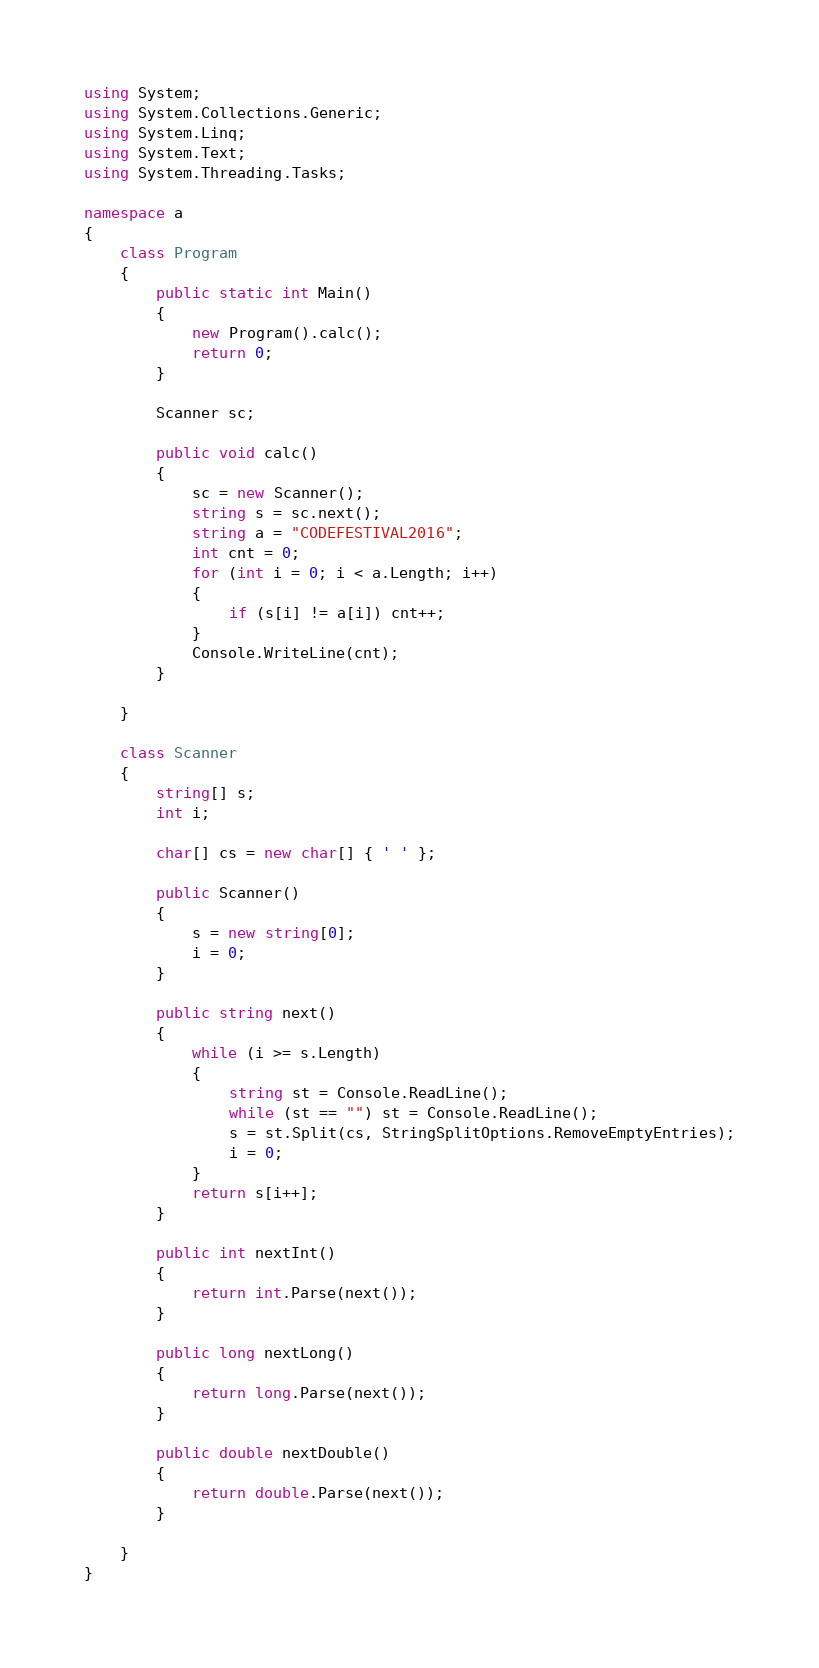<code> <loc_0><loc_0><loc_500><loc_500><_C#_>using System;
using System.Collections.Generic;
using System.Linq;
using System.Text;
using System.Threading.Tasks;

namespace a
{
    class Program
    {
        public static int Main()
        {
            new Program().calc();
            return 0;
        }

        Scanner sc;

        public void calc()
        {
            sc = new Scanner();
            string s = sc.next();
            string a = "CODEFESTIVAL2016";
            int cnt = 0;
            for (int i = 0; i < a.Length; i++)
            {
                if (s[i] != a[i]) cnt++;
            }
            Console.WriteLine(cnt);
        }

    }

    class Scanner
    {
        string[] s;
        int i;

        char[] cs = new char[] { ' ' };

        public Scanner()
        {
            s = new string[0];
            i = 0;
        }

        public string next()
        {
            while (i >= s.Length)
            {
                string st = Console.ReadLine();
                while (st == "") st = Console.ReadLine();
                s = st.Split(cs, StringSplitOptions.RemoveEmptyEntries);
                i = 0;
            }
            return s[i++];
        }

        public int nextInt()
        {
            return int.Parse(next());
        }

        public long nextLong()
        {
            return long.Parse(next());
        }

        public double nextDouble()
        {
            return double.Parse(next());
        }

    }
}</code> 